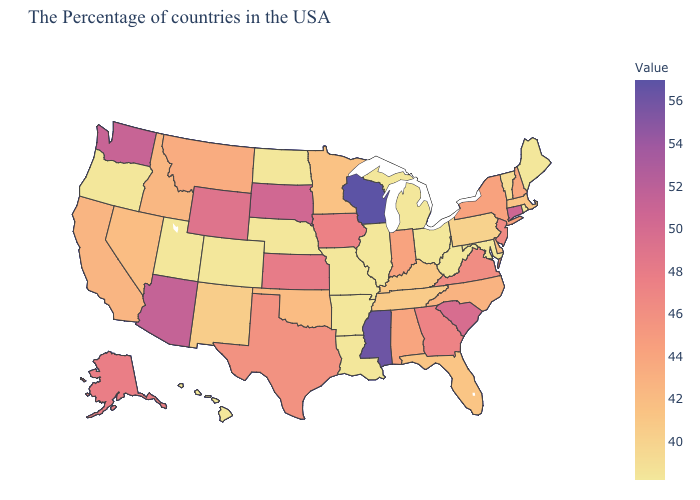Does Wisconsin have the highest value in the MidWest?
Keep it brief. Yes. Which states have the lowest value in the USA?
Answer briefly. Maine, Rhode Island, Maryland, West Virginia, Ohio, Michigan, Illinois, Louisiana, Missouri, Arkansas, Nebraska, North Dakota, Colorado, Utah, Oregon, Hawaii. Does Wisconsin have the highest value in the USA?
Concise answer only. Yes. Does Oklahoma have a higher value than New Jersey?
Write a very short answer. No. Does Hawaii have the lowest value in the West?
Concise answer only. Yes. Which states have the lowest value in the USA?
Concise answer only. Maine, Rhode Island, Maryland, West Virginia, Ohio, Michigan, Illinois, Louisiana, Missouri, Arkansas, Nebraska, North Dakota, Colorado, Utah, Oregon, Hawaii. Does Minnesota have the lowest value in the MidWest?
Give a very brief answer. No. 